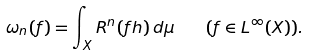<formula> <loc_0><loc_0><loc_500><loc_500>\omega _ { n } ( f ) = \int _ { X } R ^ { n } ( f h ) \, d \mu \quad ( f \in L ^ { \infty } ( X ) ) .</formula> 